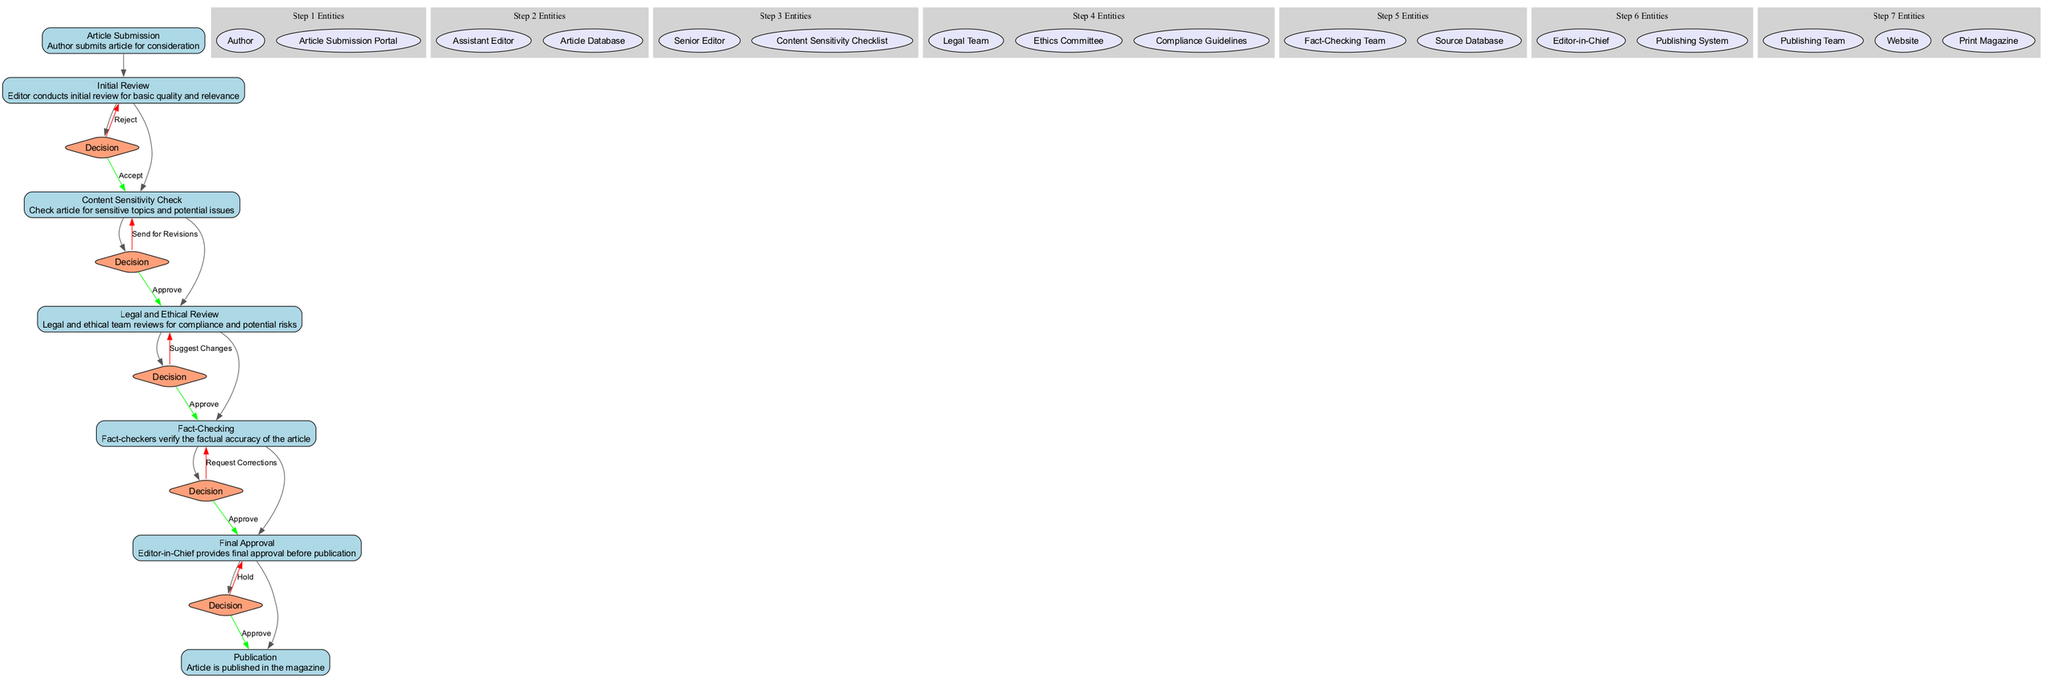What is the first step in the workflow? The first step is 'Article Submission' where the author submits an article for consideration. It is identified by the ID '1' in the workflow.
Answer: Article Submission How many decision points are in the workflow? There are three decision points in the workflow corresponding to the steps 'Initial Review', 'Content Sensitivity Check', and 'Legal and Ethical Review', each of which leads to different outcomes.
Answer: Three Which step directly follows the 'Content Sensitivity Check'? The step that directly follows 'Content Sensitivity Check', which has ID '3', is 'Legal and Ethical Review', which has ID '4'.
Answer: Legal and Ethical Review What action can result from the 'Fact-Checking' step? The 'Fact-Checking' step can result in either 'Approve' or 'Request Corrections', indicating two possible outcomes for this step in the workflow.
Answer: Approve or Request Corrections Who is responsible for the final approval of the article? The final approval of the article is the responsibility of the 'Editor-in-Chief', who reviews the article just before it is published.
Answer: Editor-in-Chief What is the last step in the workflow? The last step in the workflow is 'Publication', where the article is published in the magazine after all approvals have been secured.
Answer: Publication If an article is rejected in the 'Initial Review', what happens next? If the article is rejected in the 'Initial Review', the process reverts back to the 'Article Submission' step, as indicated by the edge from the decision node back to the previous step.
Answer: Article Submission How many entities are involved in the 'Legal and Ethical Review' step? There are three entities involved in the 'Legal and Ethical Review' step: the Legal Team, Ethics Committee, and Compliance Guidelines, indicating multiple sources of oversight for this process.
Answer: Three What is the description associated with the 'Final Approval' step? The description associated with the 'Final Approval' step is "Editor-in-Chief provides final approval before publication," which outlines the role of the Editor-in-Chief in this critical transition.
Answer: Editor-in-Chief provides final approval before publication 